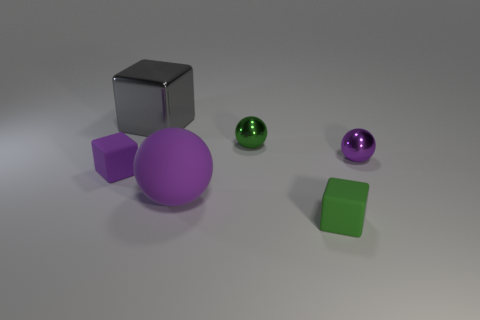Are there any other objects of the same color as the large matte thing?
Offer a very short reply. Yes. What is the color of the metal ball that is the same size as the purple metallic thing?
Offer a very short reply. Green. How many tiny objects are either green metallic blocks or metallic blocks?
Your response must be concise. 0. Are there an equal number of tiny metal balls behind the gray metal cube and spheres that are in front of the small green cube?
Your response must be concise. Yes. How many purple blocks are the same size as the green rubber block?
Offer a very short reply. 1. What number of cyan things are tiny rubber cylinders or big things?
Make the answer very short. 0. Are there the same number of purple cubes to the right of the purple cube and large cyan matte blocks?
Your answer should be compact. Yes. What is the size of the purple matte thing that is right of the gray shiny object?
Your response must be concise. Large. How many other tiny metal objects are the same shape as the tiny purple metallic thing?
Your answer should be compact. 1. What material is the thing that is both on the right side of the big purple object and in front of the purple cube?
Keep it short and to the point. Rubber. 